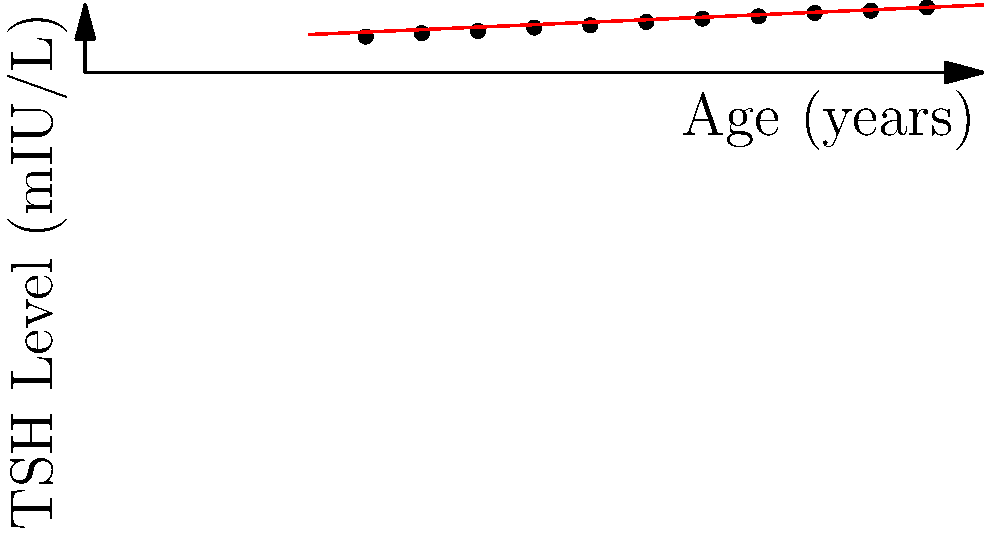Based on the scatter plot showing the relationship between patient age and thyroid-stimulating hormone (TSH) levels, what can be inferred about the impact of aging on thyroid function? How might this trend influence health policy recommendations for thyroid screening in older adults? To answer this question, let's analyze the scatter plot step-by-step:

1. Data representation: The x-axis represents patient age in years, while the y-axis shows TSH levels in mIU/L.

2. Trend observation: There is a clear positive correlation between age and TSH levels, as indicated by the upward trend of data points and the red trend line.

3. Quantitative analysis: The trend line suggests that TSH levels increase by approximately 0.044 mIU/L per year of age.

4. Physiological interpretation: This trend indicates that as people age, their TSH levels tend to rise. This could be due to:
   a) Decreased thyroid gland function with age
   b) Increased pituitary sensitivity to thyroid hormones
   c) Changes in the hypothalamic-pituitary-thyroid axis

5. Clinical implications: Higher TSH levels in older adults might not necessarily indicate hypothyroidism, as the "normal" range may shift with age.

6. Policy considerations:
   a) Age-specific reference ranges for TSH might be necessary for accurate diagnosis
   b) More frequent thyroid function screening may be beneficial for older adults
   c) Guidelines for initiating thyroid hormone replacement therapy in older adults may need to be adjusted

7. Health policy recommendations:
   a) Implement routine thyroid function screening for older adults
   b) Develop age-adjusted TSH reference ranges
   c) Educate healthcare providers on the age-related changes in thyroid function
   d) Allocate resources for further research on thyroid function in aging populations

These findings suggest that health policies should take into account the natural increase in TSH levels with age when developing screening and treatment guidelines for thyroid disorders in older adults.
Answer: TSH levels increase with age, necessitating age-specific reference ranges and more frequent thyroid screening in older adults. 